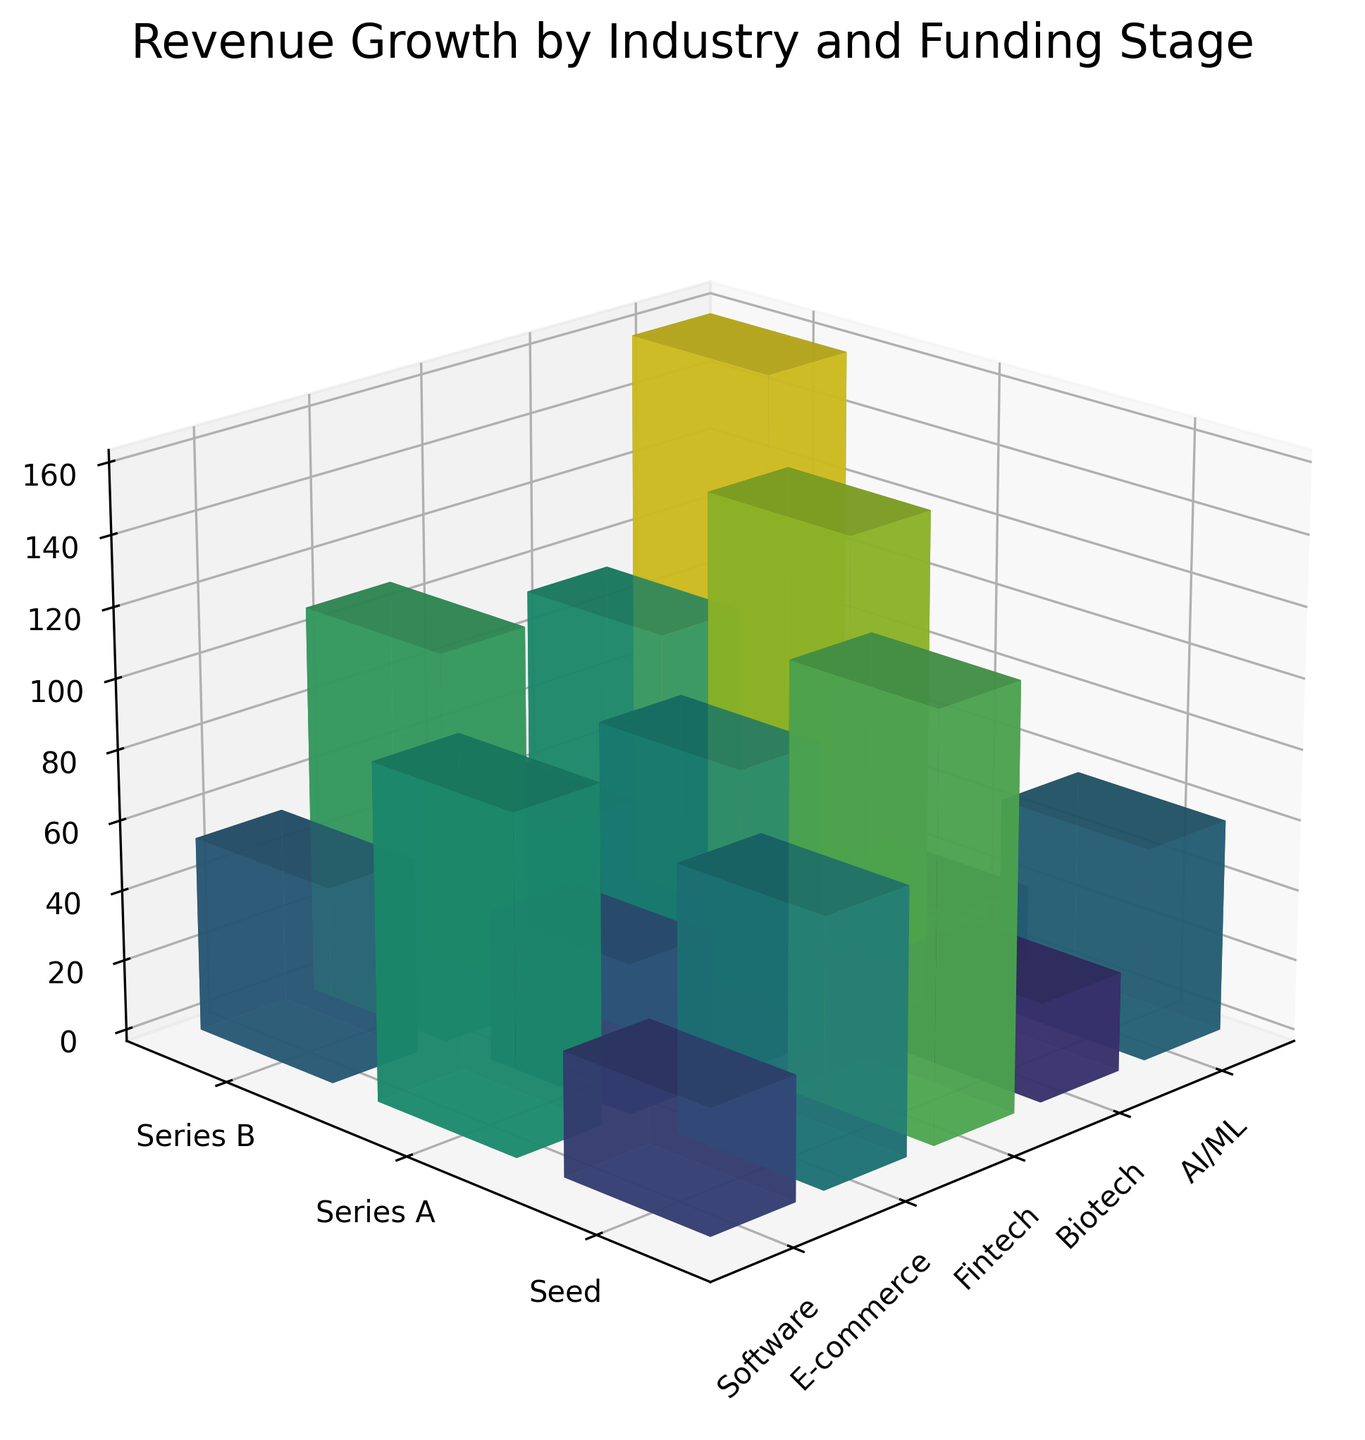What is the title of the 3D bar plot? Look at the top of the plot where the title is usually located. The title will provide the general subject of the figure.
Answer: Revenue Growth by Industry and Funding Stage Which industry has the highest revenue growth in the Series B funding stage? Identify the bars corresponding to the Series B funding stage and compare their heights. The tallest bar will indicate the industry with the highest revenue growth.
Answer: AI/ML Between the Seed and Series B funding stages, which funding stage shows more revenue growth for the E-commerce sector? Compare the heights of the bars associated with the E-commerce sector for Seed and Series B funding stages. Determine which bar is taller.
Answer: Series B What is the color trend of the bars as revenue growth increases? Observe the color gradient of the bars and note any changes in color as the revenue growth values increase. Generally, larger values are represented by more intense or lighter colors.
Answer: The color gets lighter as revenue growth increases How does the revenue growth of the Biotech industry in the Series A funding stage compare to the Seed funding stage of the Fintech industry? Find the bar representing the Biotech industry in Series A and the bar for the Fintech industry in the Seed stage. Compare the heights of these two bars.
Answer: Higher Which industry has the lowest revenue growth in the Seed funding stage? Look at the bars corresponding to the Seed funding stage and identify the shortest one, as it represents the lowest revenue growth.
Answer: Biotech Calculate the difference in revenue growth for the AI/ML industry between the Series A and Series B funding stages. Locate the bars for AI/ML in both Series A and Series B funding stages and subtract the revenue growth percentage of Series A from Series B. Series A is 95% and Series B is 160%, so the difference is 160% - 95%.
Answer: 65% Which funding stage generally shows the highest revenue growth for most industries? Compare the heights of the bars across different funding stages for each industry. The stage that generally has taller bars will show the highest revenue growth for most industries.
Answer: Series B What is the average revenue growth for the Fintech industry across all funding stages? Sum the revenue growth percentages for Fintech in all funding stages and divide by the number of stages. (42 + 85 + 140) / 3 = 89
Answer: 89% 